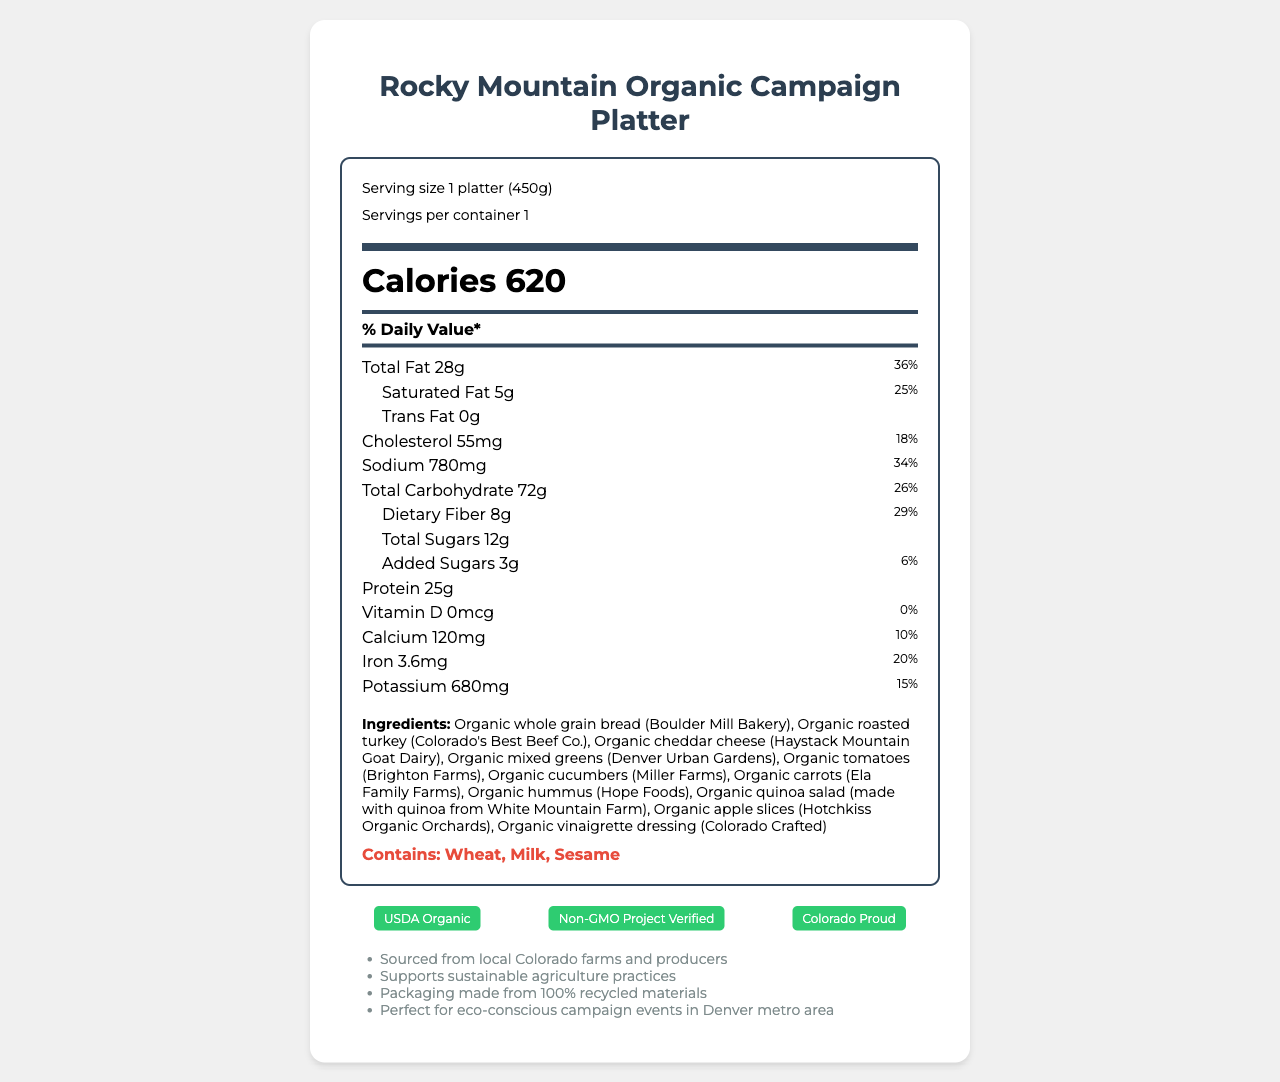What is the serving size of the Rocky Mountain Organic Campaign Platter? The serving size is mentioned at the top of the document next to the serving size label.
Answer: 1 platter (450g) How many calories are in one serving of the Rocky Mountain Organic Campaign Platter? The total calories for the platter are listed prominently in the label under the big "Calories" heading.
Answer: 620 What percentage of the daily value is the total fat content? The total fat value and its corresponding daily value percentage (36%) are listed in the nutrition label section.
Answer: 36% Name two main ingredients in the Rocky Mountain Organic Campaign Platter. The ingredients list includes these two as the first mentioned components.
Answer: Organic whole grain bread, Organic roasted turkey Which allergens are present in the Rocky Mountain Organic Campaign Platter? The allergens section at the bottom of the ingredients list mentions these allergens.
Answer: Wheat, Milk, Sesame Which nutrient has the highest daily value percentage? A. Total Fat B. Sodium C. Dietary Fiber D. Calcium The total fat has the highest daily value percentage at 36%.
Answer: A What certifications does the Rocky Mountain Organic Campaign Platter have? A. USDA Organic, Non-GMO Project Verified, Colorado Proud B. Certified Gluten-Free, Organic, No Preservatives C. Vegan, Certified Halal, Non-GMO Project Verified The listed certifications at the bottom are USDA Organic, Non-GMO Project Verified, and Colorado Proud.
Answer: A Is the Rocky Mountain Organic Campaign Platter free from added sugars? The "Added Sugars" content is listed as 3g with a 6% daily value.
Answer: No Summarize the main information included in the Rocky Mountain Organic Campaign Platter's nutrition facts label. The document provides detailed nutritional values, ingredients, and certifications. It emphasizes the organic and local nature of the ingredients and the platter's suitability for eco-conscious events.
Answer: The label provides detailed nutritional information for a single serving of the Rocky Mountain Organic Campaign Platter, indicating it contains 620 calories, 36% daily value of total fat, 34% daily value of sodium, and detailed amounts for various other nutrients. It includes a comprehensive ingredients list, highlights allergens, and displays certifications such as USDA Organic, Non-GMO Project Verified, and Colorado Proud. The platter supports sustainable agriculture and is sourced from local Colorado farms. What is the fiber content for the Rocky Mountain Organic Campaign Platter? The dietary fiber content is listed under the total carbohydrate section and is 8 grams with a 29% daily value.
Answer: 8g How much protein does the Rocky Mountain Organic Campaign Platter contain? The protein content is listed towards the end of the nutrients section.
Answer: 25 grams What local farms are part of the ingredient sourcing for this platter? The additional information and ingredients list mention all the local farms and producers involved.
Answer: Boulder Mill Bakery, Colorado's Best Beef Co., Haystack Mountain Goat Dairy, Denver Urban Gardens, Brighton Farms, Miller Farms, Ela Family Farms, Hope Foods, White Mountain Farm, Hotchkiss Organic Orchards, Colorado Crafted How much cholesterol does the platter have per serving? The cholesterol content can be found in the middle of the nutrition label and is listed as 55 milligrams, which is 18% of the daily value.
Answer: 55 mg What percentage of the daily value of calcium does the platter provide? The daily value percentage for calcium is provided next to the calcium content and is 10%.
Answer: 10% Can the exact source of the organic quinoa used in the quinoa salad be determined from the label? The quinoa is sourced from White Mountain Farm, as specified in the ingredients list.
Answer: Yes Is the Rocky Mountain Organic Campaign Platter suitable for someone with a severe gluten allergy? The platter contains wheat, as indicated in the allergens section.
Answer: No 